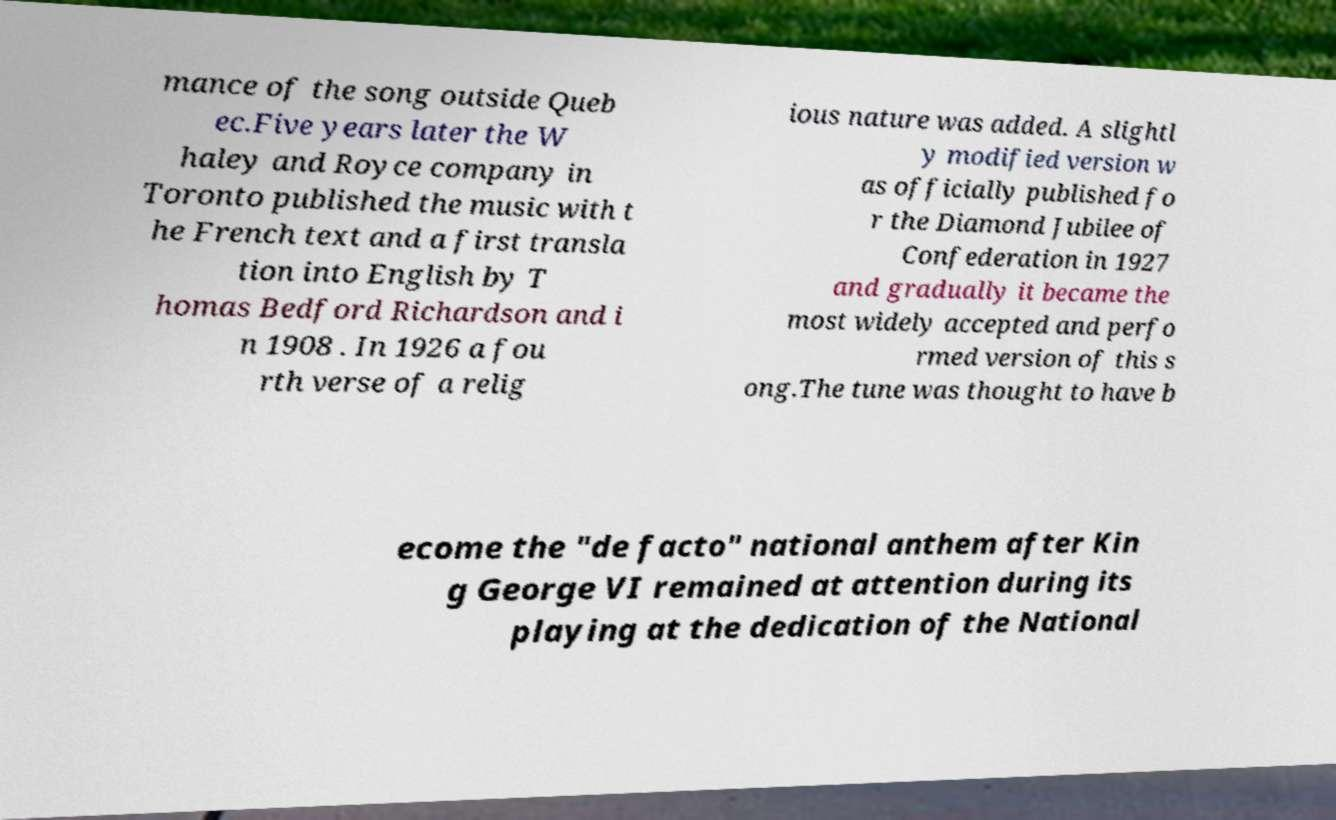Can you read and provide the text displayed in the image?This photo seems to have some interesting text. Can you extract and type it out for me? mance of the song outside Queb ec.Five years later the W haley and Royce company in Toronto published the music with t he French text and a first transla tion into English by T homas Bedford Richardson and i n 1908 . In 1926 a fou rth verse of a relig ious nature was added. A slightl y modified version w as officially published fo r the Diamond Jubilee of Confederation in 1927 and gradually it became the most widely accepted and perfo rmed version of this s ong.The tune was thought to have b ecome the "de facto" national anthem after Kin g George VI remained at attention during its playing at the dedication of the National 